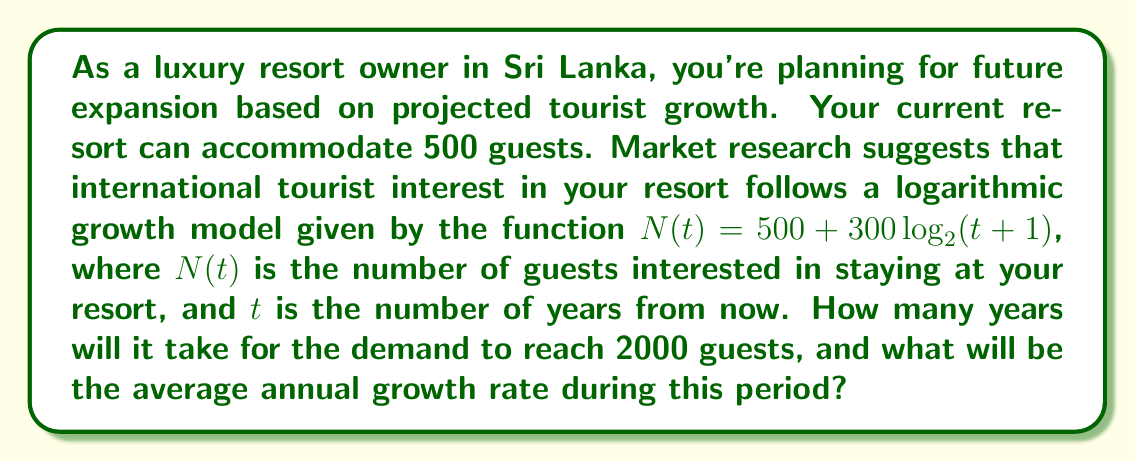What is the answer to this math problem? To solve this problem, we need to follow these steps:

1) First, we need to solve the equation:
   
   $2000 = 500 + 300 \log_2(t+1)$

2) Isolate the logarithmic term:
   
   $1500 = 300 \log_2(t+1)$
   
   $5 = \log_2(t+1)$

3) Apply $2^x$ to both sides:
   
   $2^5 = t+1$
   
   $32 = t+1$

4) Solve for $t$:
   
   $t = 31$ years

5) To calculate the average annual growth rate, we use the formula:

   $\text{Average Annual Growth Rate} = \left(\frac{\text{End Value}}{\text{Start Value}}\right)^{\frac{1}{\text{Number of Years}}} - 1$

6) Plugging in our values:

   $\text{Average Annual Growth Rate} = \left(\frac{2000}{500}\right)^{\frac{1}{31}} - 1$
   
   $= (4)^{\frac{1}{31}} - 1$
   
   $= 1.0456 - 1$
   
   $= 0.0456$ or $4.56\%$
Answer: It will take 31 years for the demand to reach 2000 guests, and the average annual growth rate during this period will be approximately 4.56%. 